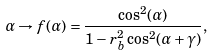Convert formula to latex. <formula><loc_0><loc_0><loc_500><loc_500>\alpha \rightarrow f ( \alpha ) = \frac { \cos ^ { 2 } ( \alpha ) } { 1 - r _ { b } ^ { 2 } \cos ^ { 2 } ( \alpha + \gamma ) } ,</formula> 